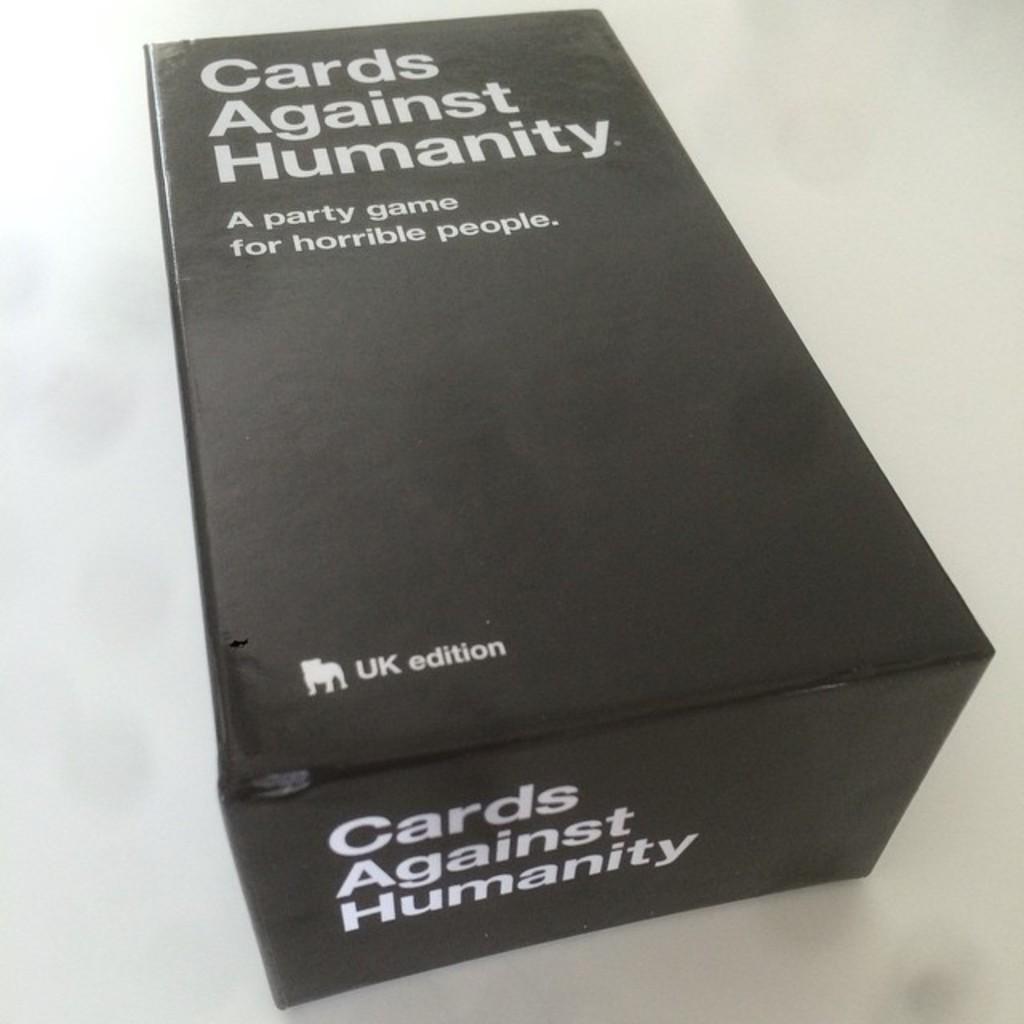Cards against what?
Provide a succinct answer. Humanity. What edition is this?
Ensure brevity in your answer.  Uk. 